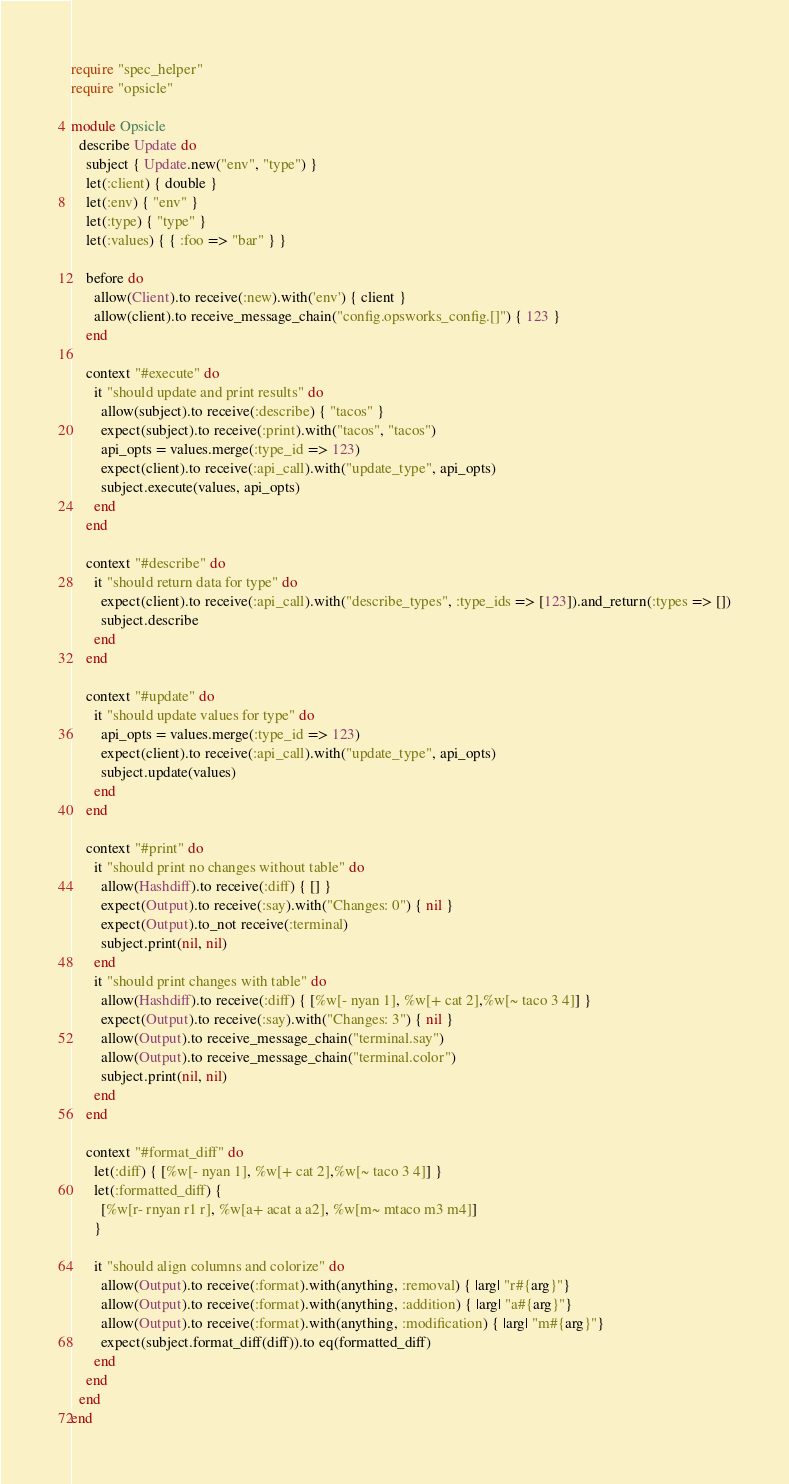Convert code to text. <code><loc_0><loc_0><loc_500><loc_500><_Ruby_>require "spec_helper"
require "opsicle"

module Opsicle
  describe Update do
    subject { Update.new("env", "type") }
    let(:client) { double }
    let(:env) { "env" }
    let(:type) { "type" }
    let(:values) { { :foo => "bar" } }

    before do
      allow(Client).to receive(:new).with('env') { client }
      allow(client).to receive_message_chain("config.opsworks_config.[]") { 123 }
    end

    context "#execute" do
      it "should update and print results" do
        allow(subject).to receive(:describe) { "tacos" }
        expect(subject).to receive(:print).with("tacos", "tacos")
        api_opts = values.merge(:type_id => 123)
        expect(client).to receive(:api_call).with("update_type", api_opts)
        subject.execute(values, api_opts)
      end
    end

    context "#describe" do
      it "should return data for type" do
        expect(client).to receive(:api_call).with("describe_types", :type_ids => [123]).and_return(:types => [])
        subject.describe
      end
    end

    context "#update" do
      it "should update values for type" do
        api_opts = values.merge(:type_id => 123)
        expect(client).to receive(:api_call).with("update_type", api_opts)
        subject.update(values)
      end
    end

    context "#print" do
      it "should print no changes without table" do
        allow(Hashdiff).to receive(:diff) { [] }
        expect(Output).to receive(:say).with("Changes: 0") { nil }
        expect(Output).to_not receive(:terminal)
        subject.print(nil, nil)
      end
      it "should print changes with table" do
        allow(Hashdiff).to receive(:diff) { [%w[- nyan 1], %w[+ cat 2],%w[~ taco 3 4]] }
        expect(Output).to receive(:say).with("Changes: 3") { nil }
        allow(Output).to receive_message_chain("terminal.say")
        allow(Output).to receive_message_chain("terminal.color")
        subject.print(nil, nil)
      end
    end

    context "#format_diff" do
      let(:diff) { [%w[- nyan 1], %w[+ cat 2],%w[~ taco 3 4]] }
      let(:formatted_diff) {
        [%w[r- rnyan r1 r], %w[a+ acat a a2], %w[m~ mtaco m3 m4]]
      }

      it "should align columns and colorize" do
        allow(Output).to receive(:format).with(anything, :removal) { |arg| "r#{arg}"}
        allow(Output).to receive(:format).with(anything, :addition) { |arg| "a#{arg}"}
        allow(Output).to receive(:format).with(anything, :modification) { |arg| "m#{arg}"}
        expect(subject.format_diff(diff)).to eq(formatted_diff)
      end
    end
  end
end
</code> 